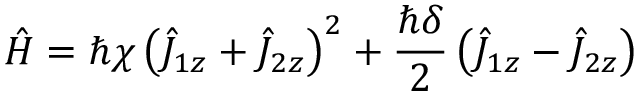Convert formula to latex. <formula><loc_0><loc_0><loc_500><loc_500>\hat { H } = \hbar { \chi } \left ( \hat { J } _ { 1 z } + \hat { J } _ { 2 z } \right ) ^ { 2 } + \frac { \hbar { \delta } } { 2 } \left ( \hat { J } _ { 1 z } - \hat { J } _ { 2 z } \right )</formula> 